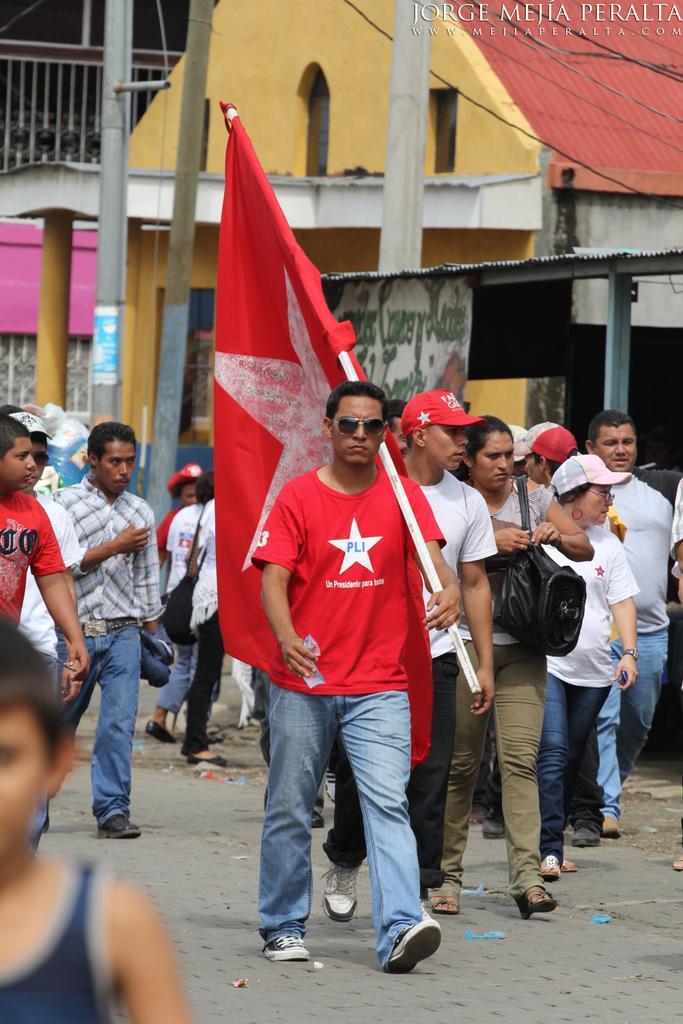Can you describe this image briefly? In this image I can see the group of people with different color dresses. I can see one person holding the flag and and and another person with the bag. I can see few people are wearing the caps. In the background I can see the poles, shed and the houses. 